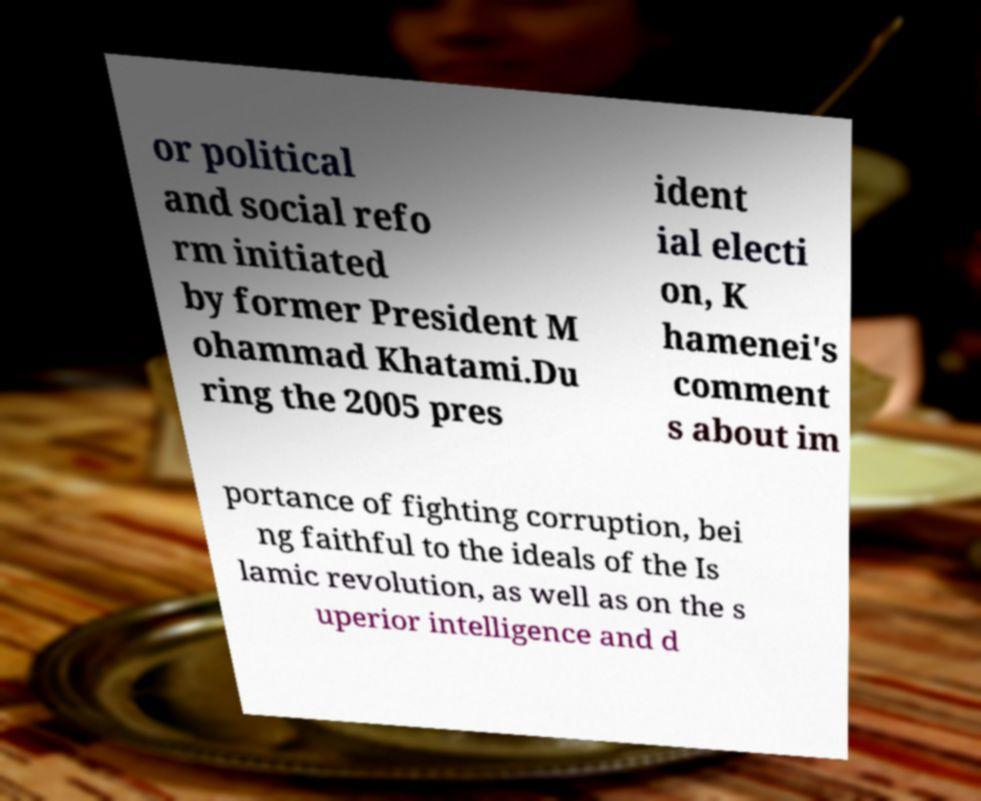Please read and relay the text visible in this image. What does it say? or political and social refo rm initiated by former President M ohammad Khatami.Du ring the 2005 pres ident ial electi on, K hamenei's comment s about im portance of fighting corruption, bei ng faithful to the ideals of the Is lamic revolution, as well as on the s uperior intelligence and d 